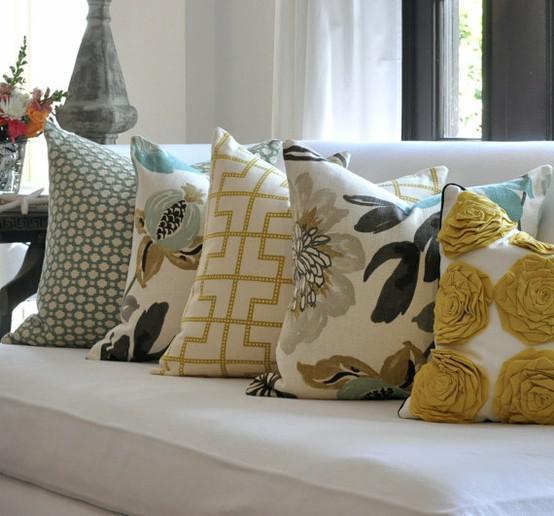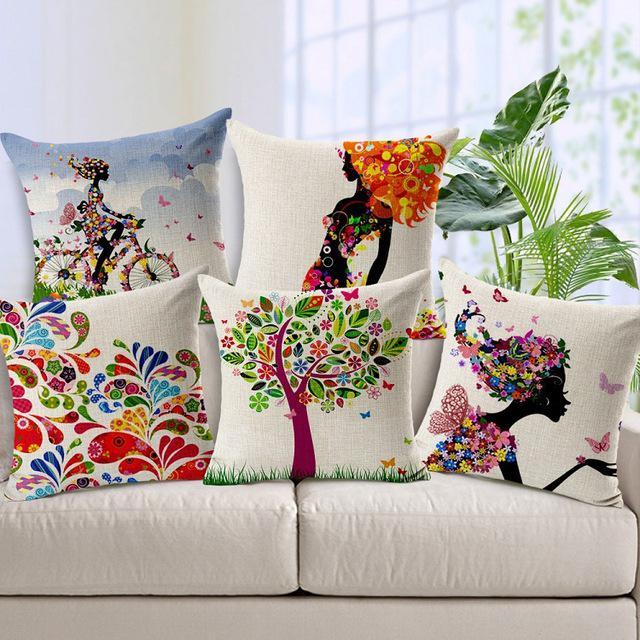The first image is the image on the left, the second image is the image on the right. Considering the images on both sides, is "There are ten pillows total." valid? Answer yes or no. Yes. 